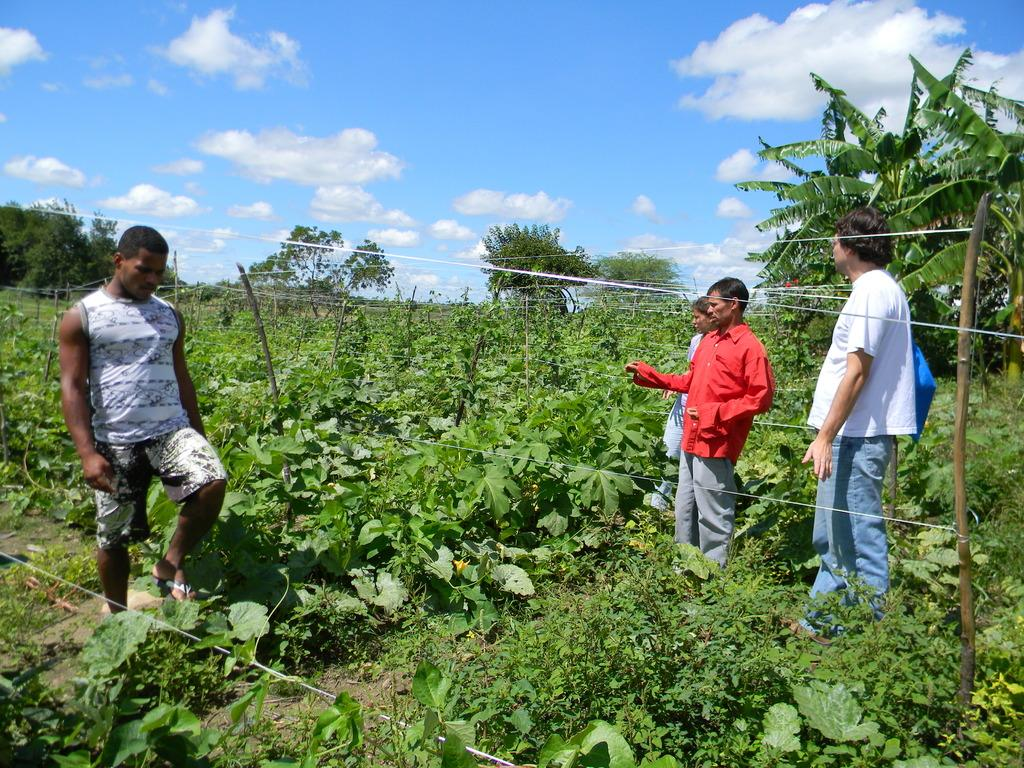What can be seen in the image involving human presence? There are people standing in the image. What type of natural elements are present in the image? There are trees in the image, and green leaves are visible. How would you describe the color of the sky in the image? The sky is blue and white in color. Are there any man-made structures or objects in the image? Yes, there are wires in the image. What type of soup is being served in the image? There is no soup present in the image. What question is being asked by the people in the image? The image does not depict any questions being asked by the people. 